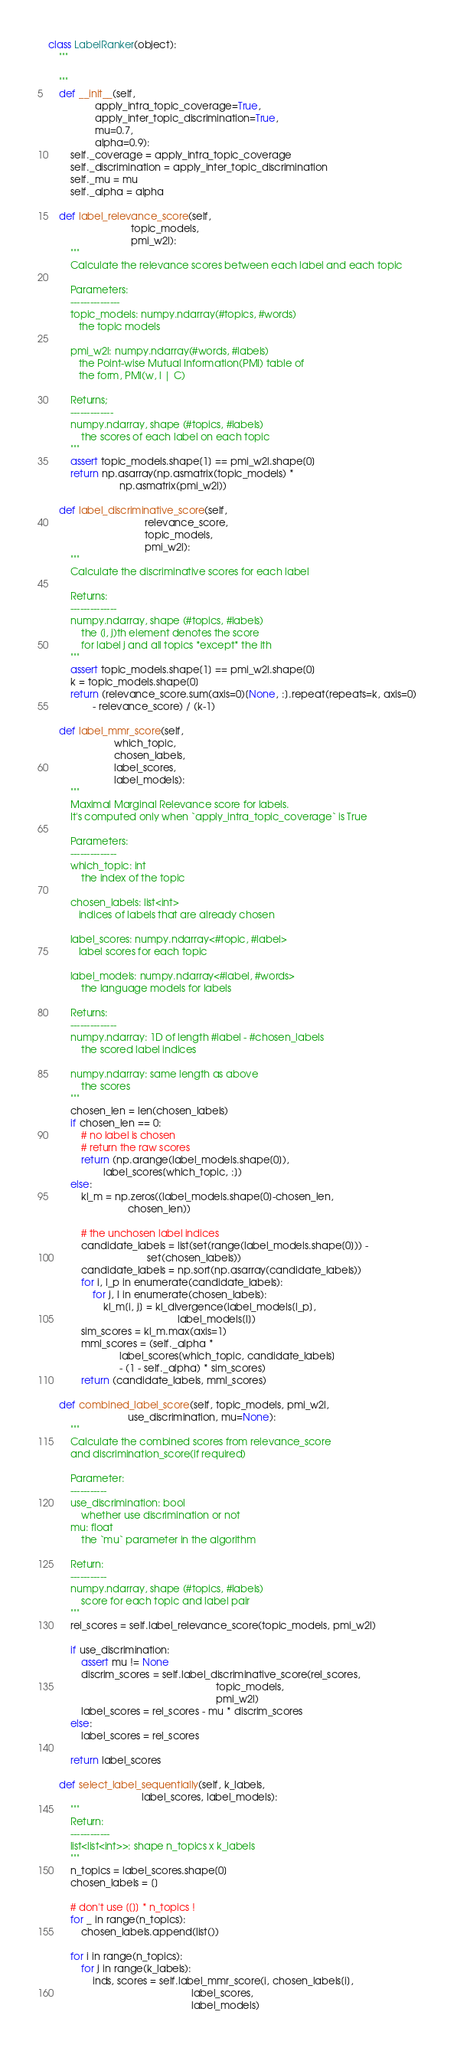<code> <loc_0><loc_0><loc_500><loc_500><_Python_>class LabelRanker(object):
    """
    
    """
    def __init__(self,
                 apply_intra_topic_coverage=True,
                 apply_inter_topic_discrimination=True,
                 mu=0.7,
                 alpha=0.9):
        self._coverage = apply_intra_topic_coverage
        self._discrimination = apply_inter_topic_discrimination
        self._mu = mu
        self._alpha = alpha

    def label_relevance_score(self,
                              topic_models,
                              pmi_w2l):
        """
        Calculate the relevance scores between each label and each topic

        Parameters:
        ---------------
        topic_models: numpy.ndarray(#topics, #words)
           the topic models

        pmi_w2l: numpy.ndarray(#words, #labels)
           the Point-wise Mutual Information(PMI) table of
           the form, PMI(w, l | C)
        
        Returns;
        -------------
        numpy.ndarray, shape (#topics, #labels)
            the scores of each label on each topic
        """
        assert topic_models.shape[1] == pmi_w2l.shape[0]
        return np.asarray(np.asmatrix(topic_models) *
                          np.asmatrix(pmi_w2l))
        
    def label_discriminative_score(self,
                                   relevance_score,
                                   topic_models,
                                   pmi_w2l):
        """
        Calculate the discriminative scores for each label
        
        Returns:
        --------------
        numpy.ndarray, shape (#topics, #labels)
            the (i, j)th element denotes the score
            for label j and all topics *except* the ith
        """
        assert topic_models.shape[1] == pmi_w2l.shape[0]
        k = topic_models.shape[0]
        return (relevance_score.sum(axis=0)[None, :].repeat(repeats=k, axis=0)
                - relevance_score) / (k-1)
        
    def label_mmr_score(self,
                        which_topic,
                        chosen_labels,
                        label_scores,
                        label_models):
        """
        Maximal Marginal Relevance score for labels.
        It's computed only when `apply_intra_topic_coverage` is True

        Parameters:
        --------------
        which_topic: int
            the index of the topic
        
        chosen_labels: list<int>
           indices of labels that are already chosen
        
        label_scores: numpy.ndarray<#topic, #label>
           label scores for each topic

        label_models: numpy.ndarray<#label, #words>
            the language models for labels

        Returns:
        --------------
        numpy.ndarray: 1D of length #label - #chosen_labels
            the scored label indices

        numpy.ndarray: same length as above
            the scores
        """
        chosen_len = len(chosen_labels)
        if chosen_len == 0:
            # no label is chosen
            # return the raw scores
            return (np.arange(label_models.shape[0]),
                    label_scores[which_topic, :])
        else:
            kl_m = np.zeros((label_models.shape[0]-chosen_len,
                             chosen_len))
            
            # the unchosen label indices
            candidate_labels = list(set(range(label_models.shape[0])) -
                                    set(chosen_labels))
            candidate_labels = np.sort(np.asarray(candidate_labels))
            for i, l_p in enumerate(candidate_labels):
                for j, l in enumerate(chosen_labels):
                    kl_m[i, j] = kl_divergence(label_models[l_p],
                                               label_models[l])
            sim_scores = kl_m.max(axis=1)
            mml_scores = (self._alpha *
                          label_scores[which_topic, candidate_labels]
                          - (1 - self._alpha) * sim_scores)
            return (candidate_labels, mml_scores)

    def combined_label_score(self, topic_models, pmi_w2l,
                             use_discrimination, mu=None):
        """
        Calculate the combined scores from relevance_score
        and discrimination_score(if required)

        Parameter:
        -----------
        use_discrimination: bool
            whether use discrimination or not
        mu: float
            the `mu` parameter in the algorithm

        Return:
        -----------
        numpy.ndarray, shape (#topics, #labels)
            score for each topic and label pair
        """
        rel_scores = self.label_relevance_score(topic_models, pmi_w2l)
        
        if use_discrimination:
            assert mu != None
            discrim_scores = self.label_discriminative_score(rel_scores,
                                                             topic_models,
                                                             pmi_w2l)
            label_scores = rel_scores - mu * discrim_scores
        else:
            label_scores = rel_scores

        return label_scores

    def select_label_sequentially(self, k_labels,
                                  label_scores, label_models):
        """
        Return:
        ------------
        list<list<int>>: shape n_topics x k_labels
        """
        n_topics = label_scores.shape[0]
        chosen_labels = []

        # don't use [[]] * n_topics !
        for _ in range(n_topics):
            chosen_labels.append(list())
            
        for i in range(n_topics):
            for j in range(k_labels):
                inds, scores = self.label_mmr_score(i, chosen_labels[i],
                                                    label_scores,
                                                    label_models)</code> 